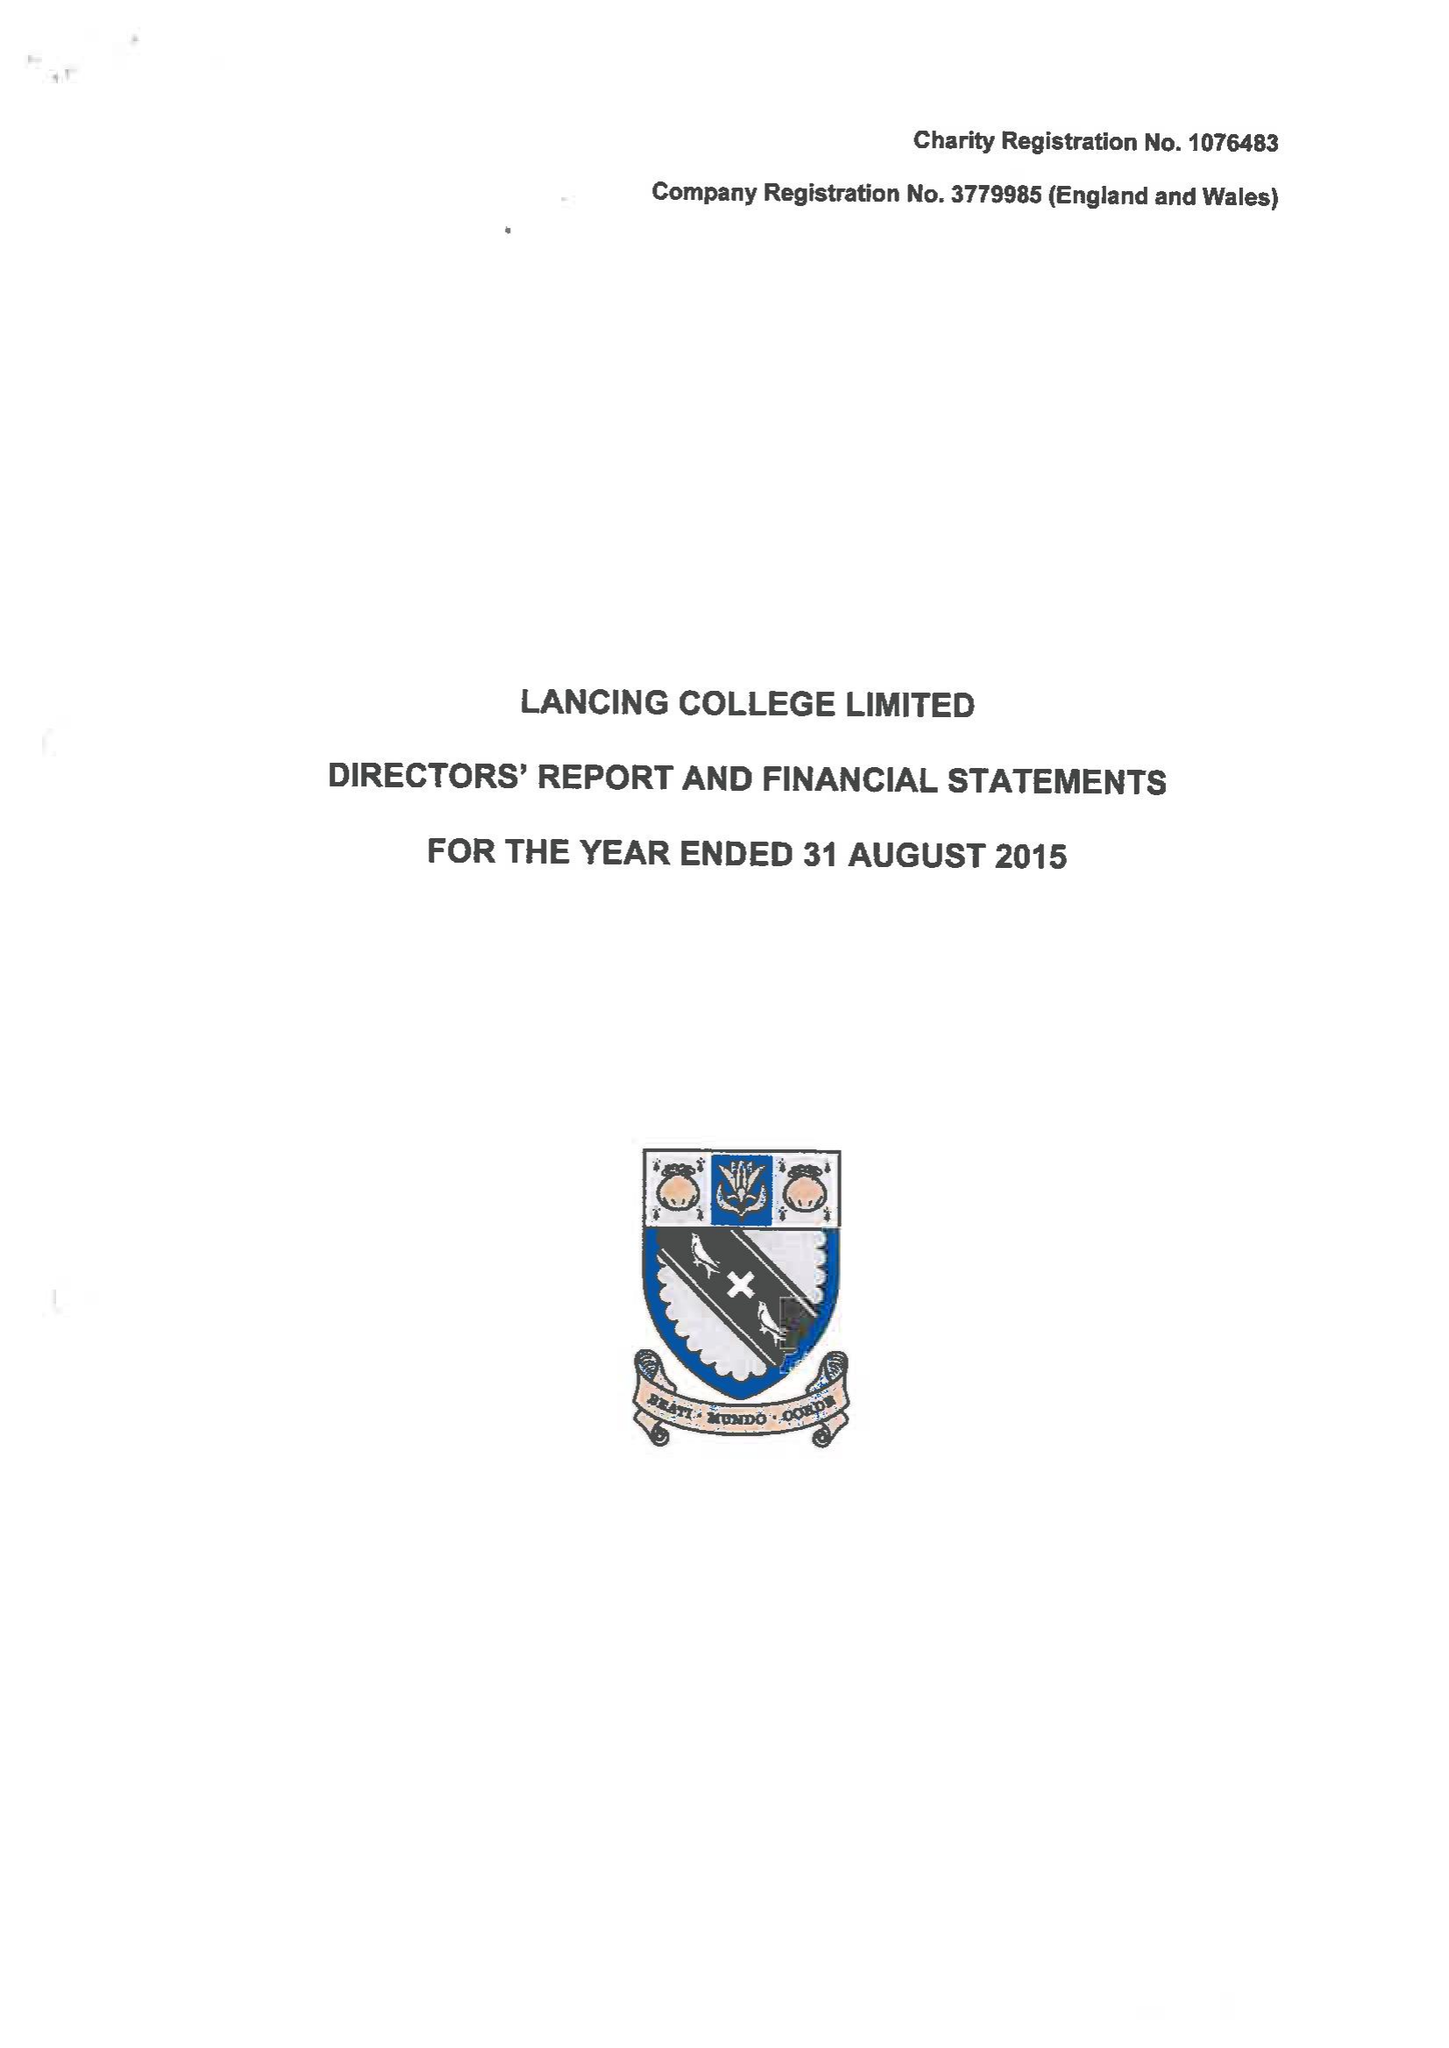What is the value for the address__street_line?
Answer the question using a single word or phrase. None 